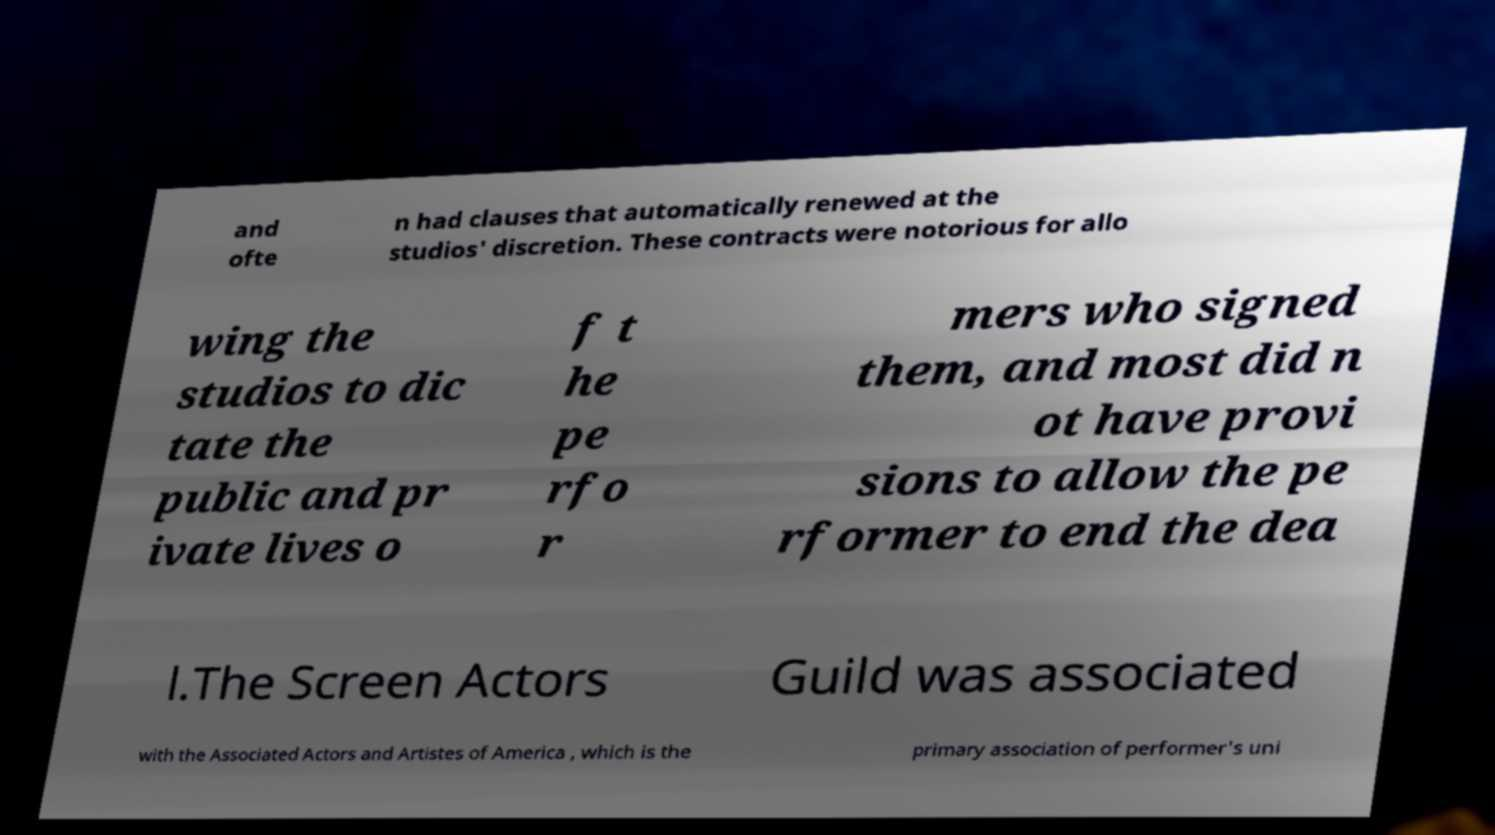There's text embedded in this image that I need extracted. Can you transcribe it verbatim? and ofte n had clauses that automatically renewed at the studios' discretion. These contracts were notorious for allo wing the studios to dic tate the public and pr ivate lives o f t he pe rfo r mers who signed them, and most did n ot have provi sions to allow the pe rformer to end the dea l.The Screen Actors Guild was associated with the Associated Actors and Artistes of America , which is the primary association of performer's uni 